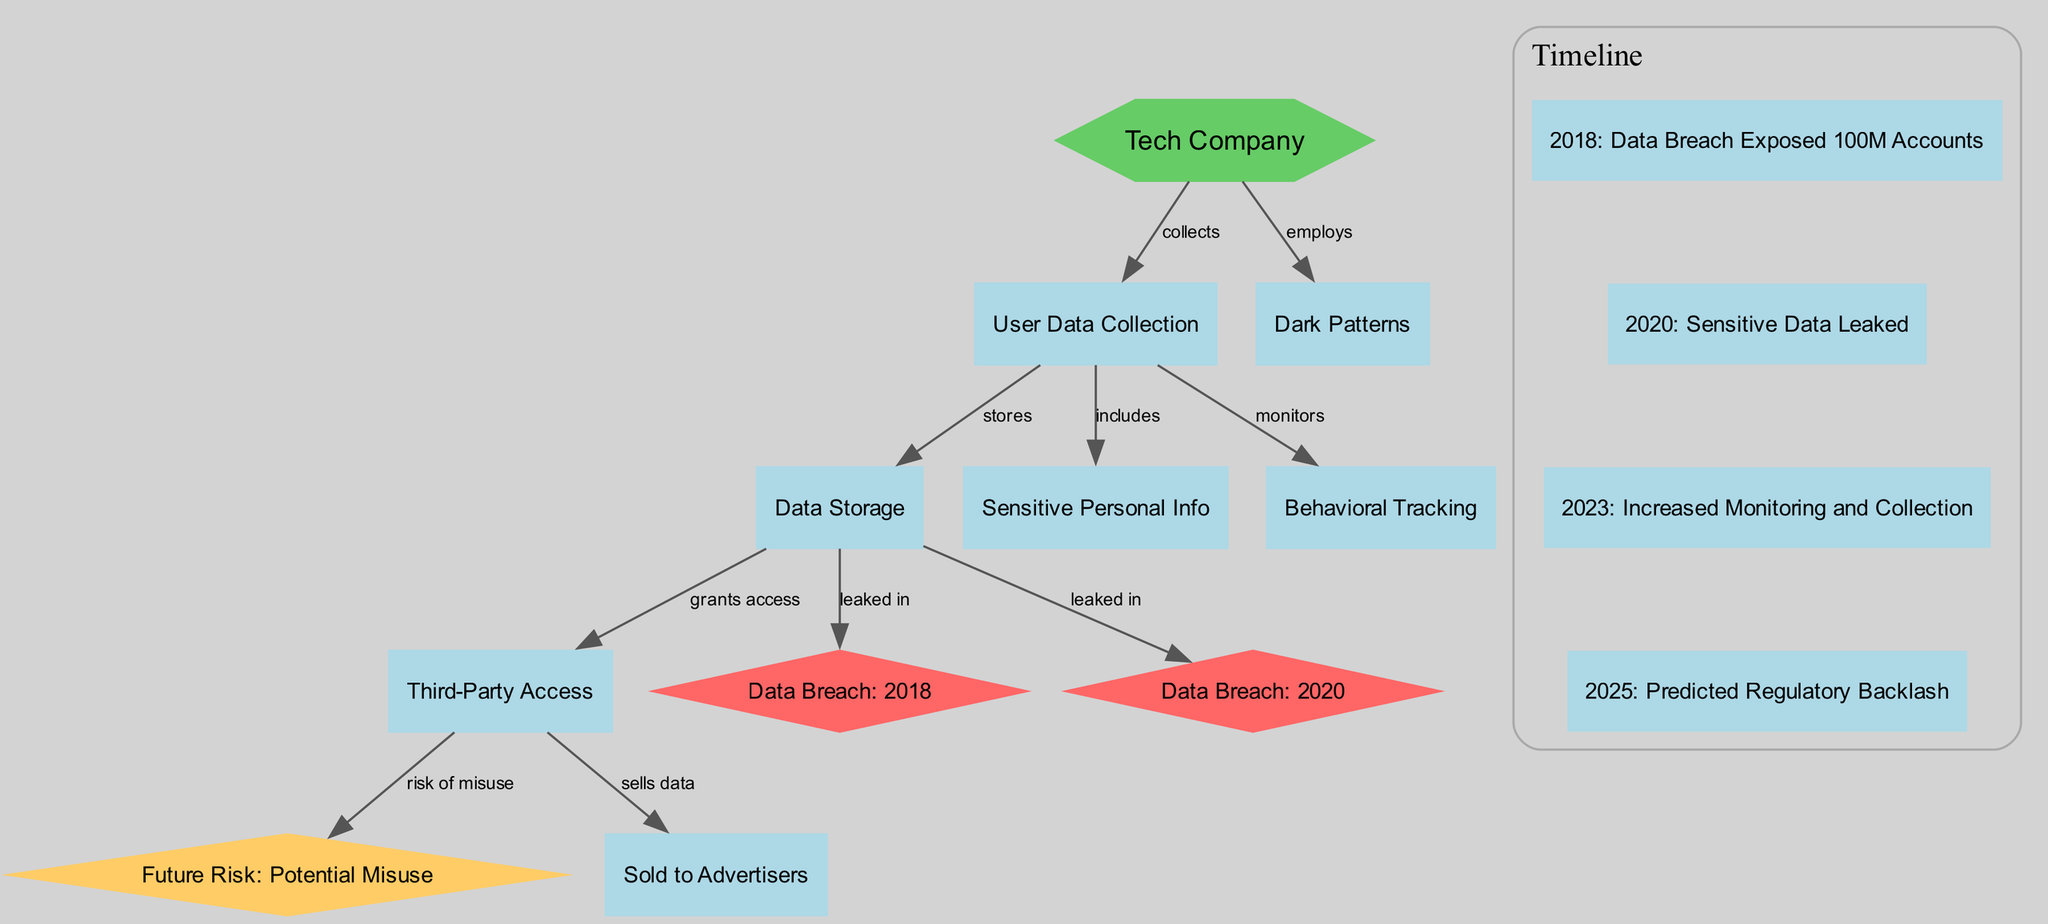What is the total number of nodes in the diagram? The diagram contains a list of nodes which includes 11 entries, such as "Tech Company," "User Data Collection," and various data breaches. Counting all of them confirms there are 11 nodes in total.
Answer: 11 What does the Tech Company collect? The edge directly from the "Tech Company" node to the "User Data Collection" node labeled "collects" indicates that the company specifically collects user data.
Answer: User Data Collection Which year did the data breach expose 100M accounts? Looking at the timeline section, the event listed for the year 2018 explicitly states that "Data Breach Exposed 100M Accounts" occurred in that year.
Answer: 2018 What type of data does the Tech Company monitor? The diagram shows an edge from "User Data Collection" to "Behavioral Tracking" labeled "monitors," indicating that the Tech Company monitors user data regarding behaviors.
Answer: Behavioral Tracking How many data breaches are indicated in the diagram? There are two specific nodes labeled "Data Breach: 2018" and "Data Breach: 2020" in the diagram. Each represents a distinct past breach, leading to a total of two breaches depicted.
Answer: 2 What future risk is associated with third-party access? The connection from the "Third-Party Access" node to the "Future Risk: Potential Misuse" node indicates that there is a risk linked to the data misuse from third parties, specifically noted as potential misuse.
Answer: Potential Misuse What happens to data after it is stored according to the diagram? The diagram shows that after the "Data Storage" node, there is a directed edge to "Third-Party Access" labeled "grants access," which suggests that stored data is subsequently accessible to third parties.
Answer: Grants access What does the company employ that may affect user experience? The diagram shows an edge from the "Tech Company" node to "Dark Patterns," indicating that the company employs dark patterns that can manipulate user experience negatively.
Answer: Dark Patterns What significant event is predicted for 2025? The timeline records a prediction for the year 2025 stating "Predicted Regulatory Backlash," which highlights a significant anticipated event pertaining to regulatory issues.
Answer: Predicted Regulatory Backlash 